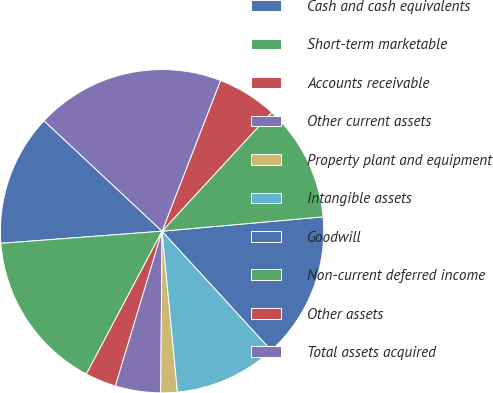<chart> <loc_0><loc_0><loc_500><loc_500><pie_chart><fcel>Cash and cash equivalents<fcel>Short-term marketable<fcel>Accounts receivable<fcel>Other current assets<fcel>Property plant and equipment<fcel>Intangible assets<fcel>Goodwill<fcel>Non-current deferred income<fcel>Other assets<fcel>Total assets acquired<nl><fcel>13.17%<fcel>16.05%<fcel>3.09%<fcel>4.53%<fcel>1.65%<fcel>10.29%<fcel>14.61%<fcel>11.73%<fcel>5.97%<fcel>18.92%<nl></chart> 